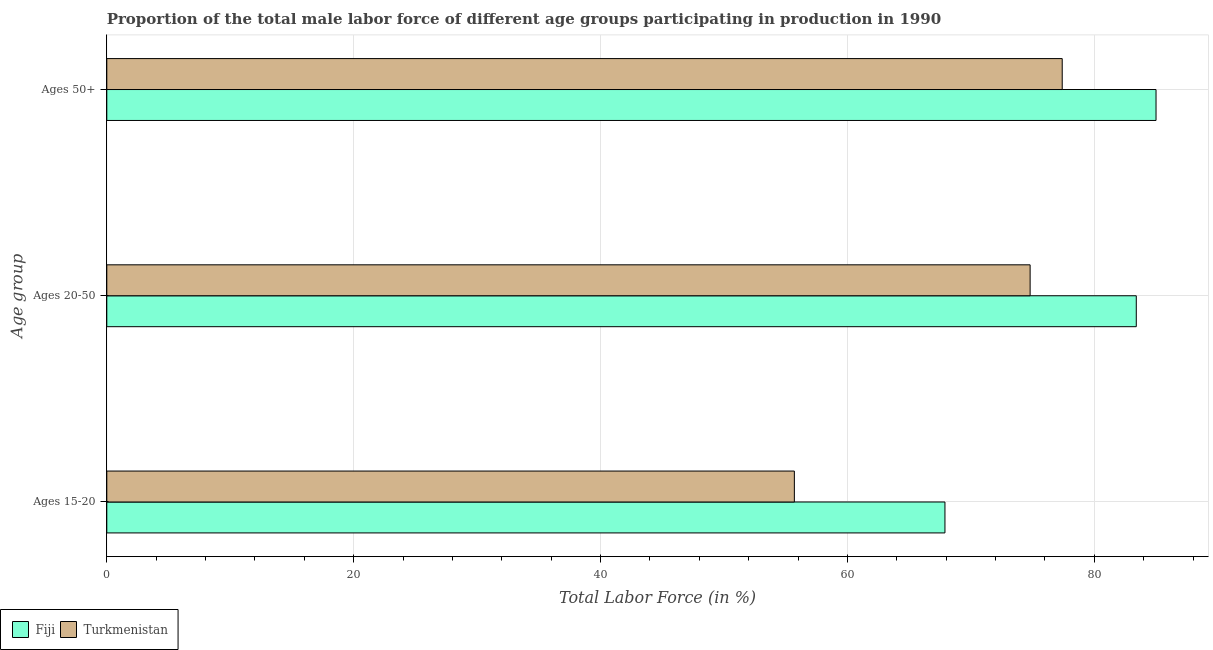How many groups of bars are there?
Provide a short and direct response. 3. Are the number of bars per tick equal to the number of legend labels?
Provide a succinct answer. Yes. Are the number of bars on each tick of the Y-axis equal?
Your answer should be compact. Yes. What is the label of the 1st group of bars from the top?
Your response must be concise. Ages 50+. What is the percentage of male labor force within the age group 15-20 in Fiji?
Your answer should be compact. 67.9. Across all countries, what is the minimum percentage of male labor force above age 50?
Make the answer very short. 77.4. In which country was the percentage of male labor force within the age group 15-20 maximum?
Offer a very short reply. Fiji. In which country was the percentage of male labor force within the age group 20-50 minimum?
Provide a short and direct response. Turkmenistan. What is the total percentage of male labor force above age 50 in the graph?
Your response must be concise. 162.4. What is the difference between the percentage of male labor force above age 50 in Turkmenistan and that in Fiji?
Provide a succinct answer. -7.6. What is the difference between the percentage of male labor force within the age group 20-50 in Fiji and the percentage of male labor force above age 50 in Turkmenistan?
Offer a very short reply. 6. What is the average percentage of male labor force within the age group 15-20 per country?
Offer a terse response. 61.8. What is the difference between the percentage of male labor force within the age group 15-20 and percentage of male labor force above age 50 in Fiji?
Make the answer very short. -17.1. What is the ratio of the percentage of male labor force within the age group 20-50 in Turkmenistan to that in Fiji?
Ensure brevity in your answer.  0.9. Is the percentage of male labor force within the age group 20-50 in Fiji less than that in Turkmenistan?
Your response must be concise. No. Is the difference between the percentage of male labor force above age 50 in Fiji and Turkmenistan greater than the difference between the percentage of male labor force within the age group 20-50 in Fiji and Turkmenistan?
Your answer should be compact. No. What is the difference between the highest and the second highest percentage of male labor force within the age group 15-20?
Your answer should be compact. 12.2. What is the difference between the highest and the lowest percentage of male labor force above age 50?
Provide a succinct answer. 7.6. What does the 2nd bar from the top in Ages 20-50 represents?
Provide a short and direct response. Fiji. What does the 2nd bar from the bottom in Ages 20-50 represents?
Your answer should be compact. Turkmenistan. How many countries are there in the graph?
Offer a very short reply. 2. Does the graph contain any zero values?
Keep it short and to the point. No. How many legend labels are there?
Offer a very short reply. 2. What is the title of the graph?
Provide a succinct answer. Proportion of the total male labor force of different age groups participating in production in 1990. What is the label or title of the Y-axis?
Keep it short and to the point. Age group. What is the Total Labor Force (in %) in Fiji in Ages 15-20?
Provide a succinct answer. 67.9. What is the Total Labor Force (in %) of Turkmenistan in Ages 15-20?
Give a very brief answer. 55.7. What is the Total Labor Force (in %) of Fiji in Ages 20-50?
Ensure brevity in your answer.  83.4. What is the Total Labor Force (in %) of Turkmenistan in Ages 20-50?
Offer a terse response. 74.8. What is the Total Labor Force (in %) of Fiji in Ages 50+?
Provide a short and direct response. 85. What is the Total Labor Force (in %) of Turkmenistan in Ages 50+?
Offer a very short reply. 77.4. Across all Age group, what is the maximum Total Labor Force (in %) of Fiji?
Your answer should be compact. 85. Across all Age group, what is the maximum Total Labor Force (in %) of Turkmenistan?
Keep it short and to the point. 77.4. Across all Age group, what is the minimum Total Labor Force (in %) in Fiji?
Your response must be concise. 67.9. Across all Age group, what is the minimum Total Labor Force (in %) in Turkmenistan?
Your answer should be compact. 55.7. What is the total Total Labor Force (in %) of Fiji in the graph?
Give a very brief answer. 236.3. What is the total Total Labor Force (in %) of Turkmenistan in the graph?
Keep it short and to the point. 207.9. What is the difference between the Total Labor Force (in %) in Fiji in Ages 15-20 and that in Ages 20-50?
Make the answer very short. -15.5. What is the difference between the Total Labor Force (in %) of Turkmenistan in Ages 15-20 and that in Ages 20-50?
Provide a short and direct response. -19.1. What is the difference between the Total Labor Force (in %) of Fiji in Ages 15-20 and that in Ages 50+?
Offer a very short reply. -17.1. What is the difference between the Total Labor Force (in %) of Turkmenistan in Ages 15-20 and that in Ages 50+?
Ensure brevity in your answer.  -21.7. What is the difference between the Total Labor Force (in %) in Turkmenistan in Ages 20-50 and that in Ages 50+?
Offer a terse response. -2.6. What is the difference between the Total Labor Force (in %) in Fiji in Ages 20-50 and the Total Labor Force (in %) in Turkmenistan in Ages 50+?
Provide a succinct answer. 6. What is the average Total Labor Force (in %) in Fiji per Age group?
Offer a very short reply. 78.77. What is the average Total Labor Force (in %) in Turkmenistan per Age group?
Provide a succinct answer. 69.3. What is the difference between the Total Labor Force (in %) of Fiji and Total Labor Force (in %) of Turkmenistan in Ages 15-20?
Keep it short and to the point. 12.2. What is the difference between the Total Labor Force (in %) in Fiji and Total Labor Force (in %) in Turkmenistan in Ages 50+?
Ensure brevity in your answer.  7.6. What is the ratio of the Total Labor Force (in %) in Fiji in Ages 15-20 to that in Ages 20-50?
Ensure brevity in your answer.  0.81. What is the ratio of the Total Labor Force (in %) in Turkmenistan in Ages 15-20 to that in Ages 20-50?
Ensure brevity in your answer.  0.74. What is the ratio of the Total Labor Force (in %) in Fiji in Ages 15-20 to that in Ages 50+?
Ensure brevity in your answer.  0.8. What is the ratio of the Total Labor Force (in %) in Turkmenistan in Ages 15-20 to that in Ages 50+?
Give a very brief answer. 0.72. What is the ratio of the Total Labor Force (in %) in Fiji in Ages 20-50 to that in Ages 50+?
Provide a succinct answer. 0.98. What is the ratio of the Total Labor Force (in %) in Turkmenistan in Ages 20-50 to that in Ages 50+?
Offer a very short reply. 0.97. What is the difference between the highest and the second highest Total Labor Force (in %) in Fiji?
Offer a very short reply. 1.6. What is the difference between the highest and the second highest Total Labor Force (in %) of Turkmenistan?
Give a very brief answer. 2.6. What is the difference between the highest and the lowest Total Labor Force (in %) in Fiji?
Give a very brief answer. 17.1. What is the difference between the highest and the lowest Total Labor Force (in %) in Turkmenistan?
Your answer should be compact. 21.7. 